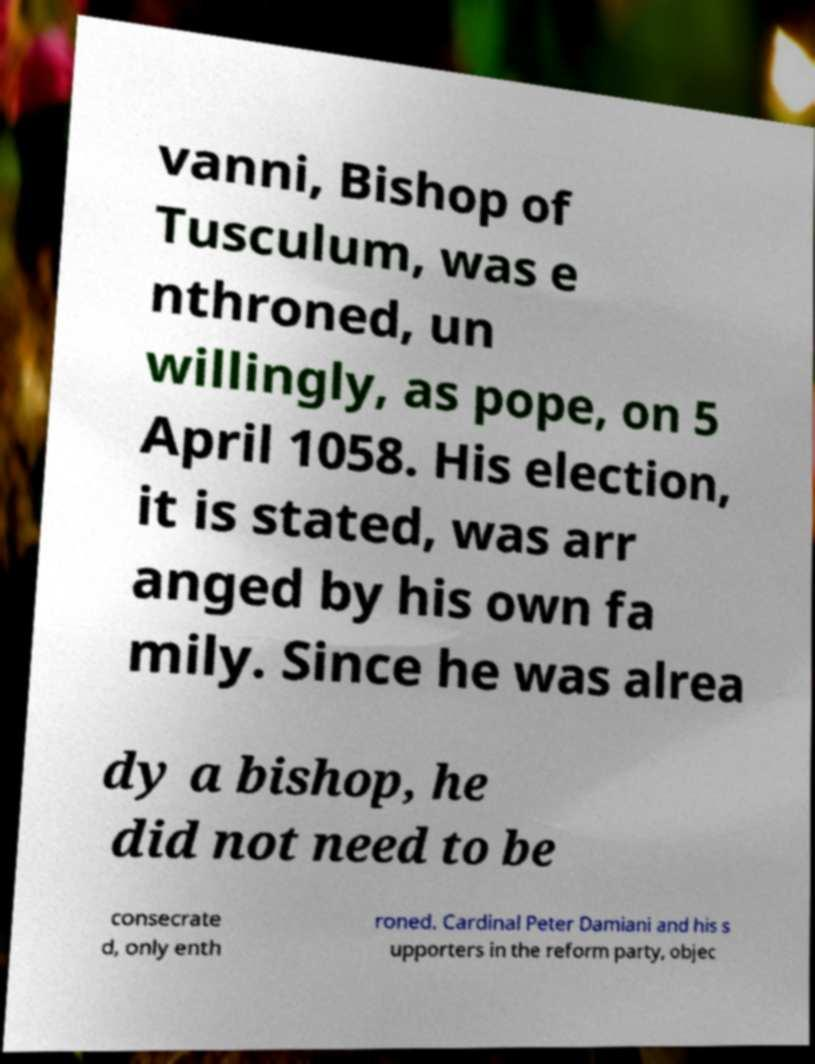Can you read and provide the text displayed in the image?This photo seems to have some interesting text. Can you extract and type it out for me? vanni, Bishop of Tusculum, was e nthroned, un willingly, as pope, on 5 April 1058. His election, it is stated, was arr anged by his own fa mily. Since he was alrea dy a bishop, he did not need to be consecrate d, only enth roned. Cardinal Peter Damiani and his s upporters in the reform party, objec 